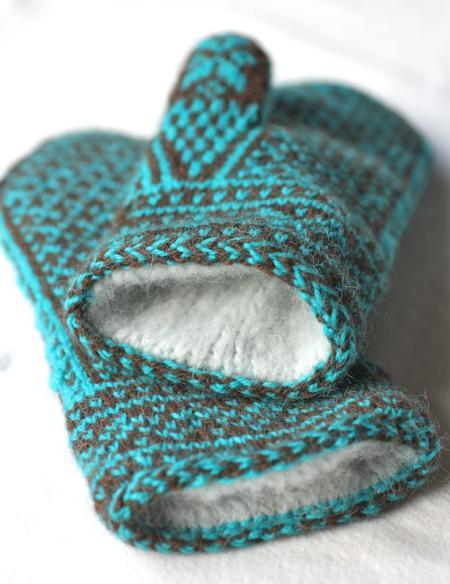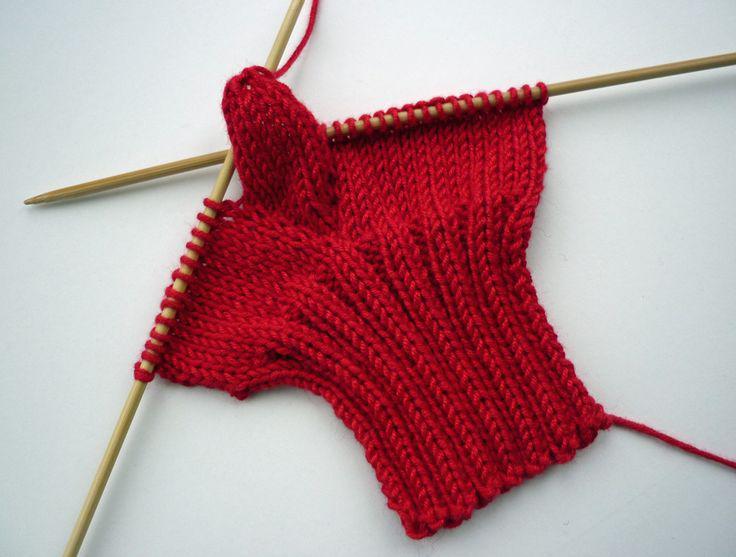The first image is the image on the left, the second image is the image on the right. Considering the images on both sides, is "There is a pair of mittens and one is in the process of being knitted." valid? Answer yes or no. Yes. The first image is the image on the left, the second image is the image on the right. For the images shown, is this caption "An image shows some type of needle inserted into the yarn of a mitten." true? Answer yes or no. Yes. 